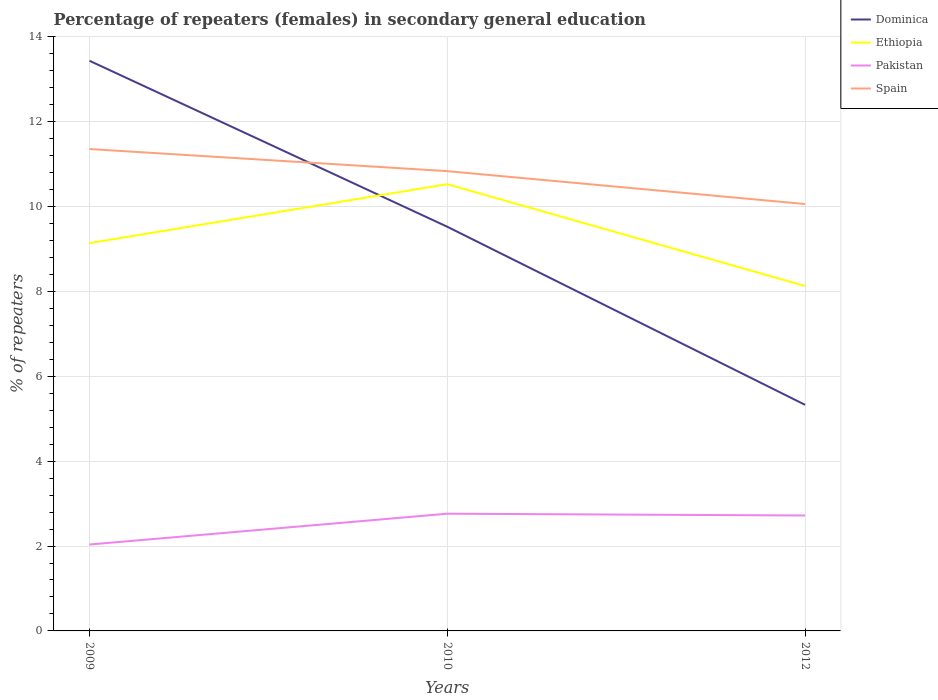Does the line corresponding to Pakistan intersect with the line corresponding to Spain?
Provide a short and direct response. No. Is the number of lines equal to the number of legend labels?
Keep it short and to the point. Yes. Across all years, what is the maximum percentage of female repeaters in Ethiopia?
Offer a very short reply. 8.13. In which year was the percentage of female repeaters in Pakistan maximum?
Your answer should be very brief. 2009. What is the total percentage of female repeaters in Ethiopia in the graph?
Offer a terse response. 1.01. What is the difference between the highest and the second highest percentage of female repeaters in Dominica?
Ensure brevity in your answer.  8.11. How many lines are there?
Provide a short and direct response. 4. How many years are there in the graph?
Offer a very short reply. 3. Does the graph contain grids?
Your answer should be very brief. Yes. Where does the legend appear in the graph?
Offer a terse response. Top right. How many legend labels are there?
Your answer should be very brief. 4. What is the title of the graph?
Make the answer very short. Percentage of repeaters (females) in secondary general education. What is the label or title of the Y-axis?
Make the answer very short. % of repeaters. What is the % of repeaters of Dominica in 2009?
Offer a terse response. 13.43. What is the % of repeaters in Ethiopia in 2009?
Your answer should be compact. 9.14. What is the % of repeaters of Pakistan in 2009?
Provide a short and direct response. 2.04. What is the % of repeaters of Spain in 2009?
Make the answer very short. 11.36. What is the % of repeaters of Dominica in 2010?
Offer a terse response. 9.52. What is the % of repeaters of Ethiopia in 2010?
Ensure brevity in your answer.  10.53. What is the % of repeaters of Pakistan in 2010?
Your response must be concise. 2.76. What is the % of repeaters in Spain in 2010?
Offer a terse response. 10.83. What is the % of repeaters in Dominica in 2012?
Keep it short and to the point. 5.33. What is the % of repeaters in Ethiopia in 2012?
Keep it short and to the point. 8.13. What is the % of repeaters of Pakistan in 2012?
Offer a very short reply. 2.72. What is the % of repeaters of Spain in 2012?
Provide a succinct answer. 10.06. Across all years, what is the maximum % of repeaters in Dominica?
Provide a short and direct response. 13.43. Across all years, what is the maximum % of repeaters in Ethiopia?
Your response must be concise. 10.53. Across all years, what is the maximum % of repeaters of Pakistan?
Provide a short and direct response. 2.76. Across all years, what is the maximum % of repeaters of Spain?
Offer a very short reply. 11.36. Across all years, what is the minimum % of repeaters in Dominica?
Offer a terse response. 5.33. Across all years, what is the minimum % of repeaters of Ethiopia?
Make the answer very short. 8.13. Across all years, what is the minimum % of repeaters in Pakistan?
Make the answer very short. 2.04. Across all years, what is the minimum % of repeaters of Spain?
Give a very brief answer. 10.06. What is the total % of repeaters in Dominica in the graph?
Offer a terse response. 28.29. What is the total % of repeaters of Ethiopia in the graph?
Your answer should be very brief. 27.79. What is the total % of repeaters in Pakistan in the graph?
Your response must be concise. 7.52. What is the total % of repeaters in Spain in the graph?
Give a very brief answer. 32.25. What is the difference between the % of repeaters in Dominica in 2009 and that in 2010?
Provide a short and direct response. 3.91. What is the difference between the % of repeaters in Ethiopia in 2009 and that in 2010?
Your answer should be compact. -1.39. What is the difference between the % of repeaters in Pakistan in 2009 and that in 2010?
Keep it short and to the point. -0.73. What is the difference between the % of repeaters of Spain in 2009 and that in 2010?
Your answer should be compact. 0.52. What is the difference between the % of repeaters of Dominica in 2009 and that in 2012?
Your response must be concise. 8.11. What is the difference between the % of repeaters in Ethiopia in 2009 and that in 2012?
Ensure brevity in your answer.  1.01. What is the difference between the % of repeaters in Pakistan in 2009 and that in 2012?
Your answer should be very brief. -0.68. What is the difference between the % of repeaters of Spain in 2009 and that in 2012?
Your response must be concise. 1.3. What is the difference between the % of repeaters of Dominica in 2010 and that in 2012?
Your answer should be very brief. 4.2. What is the difference between the % of repeaters in Ethiopia in 2010 and that in 2012?
Provide a succinct answer. 2.4. What is the difference between the % of repeaters of Pakistan in 2010 and that in 2012?
Your response must be concise. 0.04. What is the difference between the % of repeaters in Spain in 2010 and that in 2012?
Your answer should be compact. 0.77. What is the difference between the % of repeaters of Dominica in 2009 and the % of repeaters of Ethiopia in 2010?
Your answer should be compact. 2.91. What is the difference between the % of repeaters in Dominica in 2009 and the % of repeaters in Pakistan in 2010?
Give a very brief answer. 10.67. What is the difference between the % of repeaters of Dominica in 2009 and the % of repeaters of Spain in 2010?
Provide a succinct answer. 2.6. What is the difference between the % of repeaters in Ethiopia in 2009 and the % of repeaters in Pakistan in 2010?
Provide a succinct answer. 6.38. What is the difference between the % of repeaters in Ethiopia in 2009 and the % of repeaters in Spain in 2010?
Make the answer very short. -1.7. What is the difference between the % of repeaters in Pakistan in 2009 and the % of repeaters in Spain in 2010?
Provide a succinct answer. -8.8. What is the difference between the % of repeaters of Dominica in 2009 and the % of repeaters of Ethiopia in 2012?
Offer a very short reply. 5.31. What is the difference between the % of repeaters in Dominica in 2009 and the % of repeaters in Pakistan in 2012?
Offer a very short reply. 10.72. What is the difference between the % of repeaters in Dominica in 2009 and the % of repeaters in Spain in 2012?
Keep it short and to the point. 3.38. What is the difference between the % of repeaters in Ethiopia in 2009 and the % of repeaters in Pakistan in 2012?
Your answer should be compact. 6.42. What is the difference between the % of repeaters of Ethiopia in 2009 and the % of repeaters of Spain in 2012?
Keep it short and to the point. -0.92. What is the difference between the % of repeaters of Pakistan in 2009 and the % of repeaters of Spain in 2012?
Offer a very short reply. -8.02. What is the difference between the % of repeaters of Dominica in 2010 and the % of repeaters of Ethiopia in 2012?
Your response must be concise. 1.4. What is the difference between the % of repeaters in Dominica in 2010 and the % of repeaters in Pakistan in 2012?
Give a very brief answer. 6.8. What is the difference between the % of repeaters in Dominica in 2010 and the % of repeaters in Spain in 2012?
Your answer should be very brief. -0.54. What is the difference between the % of repeaters in Ethiopia in 2010 and the % of repeaters in Pakistan in 2012?
Offer a very short reply. 7.81. What is the difference between the % of repeaters of Ethiopia in 2010 and the % of repeaters of Spain in 2012?
Offer a very short reply. 0.47. What is the difference between the % of repeaters in Pakistan in 2010 and the % of repeaters in Spain in 2012?
Offer a very short reply. -7.3. What is the average % of repeaters of Dominica per year?
Make the answer very short. 9.43. What is the average % of repeaters of Ethiopia per year?
Ensure brevity in your answer.  9.26. What is the average % of repeaters in Pakistan per year?
Provide a short and direct response. 2.51. What is the average % of repeaters in Spain per year?
Provide a short and direct response. 10.75. In the year 2009, what is the difference between the % of repeaters of Dominica and % of repeaters of Ethiopia?
Offer a very short reply. 4.3. In the year 2009, what is the difference between the % of repeaters in Dominica and % of repeaters in Pakistan?
Provide a succinct answer. 11.4. In the year 2009, what is the difference between the % of repeaters of Dominica and % of repeaters of Spain?
Provide a succinct answer. 2.08. In the year 2009, what is the difference between the % of repeaters in Ethiopia and % of repeaters in Pakistan?
Keep it short and to the point. 7.1. In the year 2009, what is the difference between the % of repeaters in Ethiopia and % of repeaters in Spain?
Offer a terse response. -2.22. In the year 2009, what is the difference between the % of repeaters of Pakistan and % of repeaters of Spain?
Ensure brevity in your answer.  -9.32. In the year 2010, what is the difference between the % of repeaters of Dominica and % of repeaters of Ethiopia?
Your answer should be compact. -1. In the year 2010, what is the difference between the % of repeaters of Dominica and % of repeaters of Pakistan?
Your answer should be compact. 6.76. In the year 2010, what is the difference between the % of repeaters in Dominica and % of repeaters in Spain?
Keep it short and to the point. -1.31. In the year 2010, what is the difference between the % of repeaters of Ethiopia and % of repeaters of Pakistan?
Your answer should be very brief. 7.76. In the year 2010, what is the difference between the % of repeaters in Ethiopia and % of repeaters in Spain?
Make the answer very short. -0.31. In the year 2010, what is the difference between the % of repeaters of Pakistan and % of repeaters of Spain?
Your answer should be very brief. -8.07. In the year 2012, what is the difference between the % of repeaters of Dominica and % of repeaters of Ethiopia?
Offer a terse response. -2.8. In the year 2012, what is the difference between the % of repeaters of Dominica and % of repeaters of Pakistan?
Offer a very short reply. 2.61. In the year 2012, what is the difference between the % of repeaters in Dominica and % of repeaters in Spain?
Make the answer very short. -4.73. In the year 2012, what is the difference between the % of repeaters in Ethiopia and % of repeaters in Pakistan?
Your response must be concise. 5.41. In the year 2012, what is the difference between the % of repeaters in Ethiopia and % of repeaters in Spain?
Keep it short and to the point. -1.93. In the year 2012, what is the difference between the % of repeaters of Pakistan and % of repeaters of Spain?
Ensure brevity in your answer.  -7.34. What is the ratio of the % of repeaters of Dominica in 2009 to that in 2010?
Make the answer very short. 1.41. What is the ratio of the % of repeaters of Ethiopia in 2009 to that in 2010?
Make the answer very short. 0.87. What is the ratio of the % of repeaters of Pakistan in 2009 to that in 2010?
Make the answer very short. 0.74. What is the ratio of the % of repeaters in Spain in 2009 to that in 2010?
Offer a terse response. 1.05. What is the ratio of the % of repeaters of Dominica in 2009 to that in 2012?
Your answer should be very brief. 2.52. What is the ratio of the % of repeaters of Ethiopia in 2009 to that in 2012?
Offer a terse response. 1.12. What is the ratio of the % of repeaters in Pakistan in 2009 to that in 2012?
Ensure brevity in your answer.  0.75. What is the ratio of the % of repeaters of Spain in 2009 to that in 2012?
Ensure brevity in your answer.  1.13. What is the ratio of the % of repeaters in Dominica in 2010 to that in 2012?
Provide a short and direct response. 1.79. What is the ratio of the % of repeaters in Ethiopia in 2010 to that in 2012?
Ensure brevity in your answer.  1.3. What is the ratio of the % of repeaters in Pakistan in 2010 to that in 2012?
Provide a succinct answer. 1.02. What is the ratio of the % of repeaters in Spain in 2010 to that in 2012?
Offer a very short reply. 1.08. What is the difference between the highest and the second highest % of repeaters in Dominica?
Your answer should be compact. 3.91. What is the difference between the highest and the second highest % of repeaters in Ethiopia?
Your response must be concise. 1.39. What is the difference between the highest and the second highest % of repeaters of Pakistan?
Keep it short and to the point. 0.04. What is the difference between the highest and the second highest % of repeaters in Spain?
Keep it short and to the point. 0.52. What is the difference between the highest and the lowest % of repeaters in Dominica?
Make the answer very short. 8.11. What is the difference between the highest and the lowest % of repeaters of Ethiopia?
Provide a short and direct response. 2.4. What is the difference between the highest and the lowest % of repeaters in Pakistan?
Offer a very short reply. 0.73. What is the difference between the highest and the lowest % of repeaters of Spain?
Offer a terse response. 1.3. 